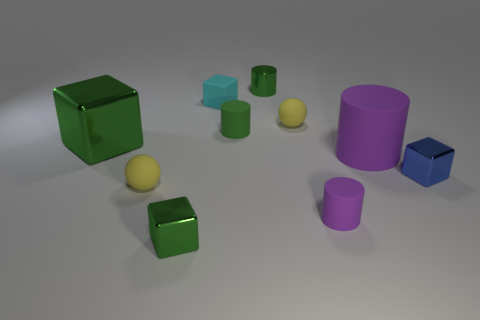Subtract all cyan blocks. Subtract all red balls. How many blocks are left? 3 Subtract all cylinders. How many objects are left? 6 Add 4 yellow things. How many yellow things are left? 6 Add 9 big blue metallic things. How many big blue metallic things exist? 9 Subtract 0 green spheres. How many objects are left? 10 Subtract all tiny metal things. Subtract all green metal blocks. How many objects are left? 5 